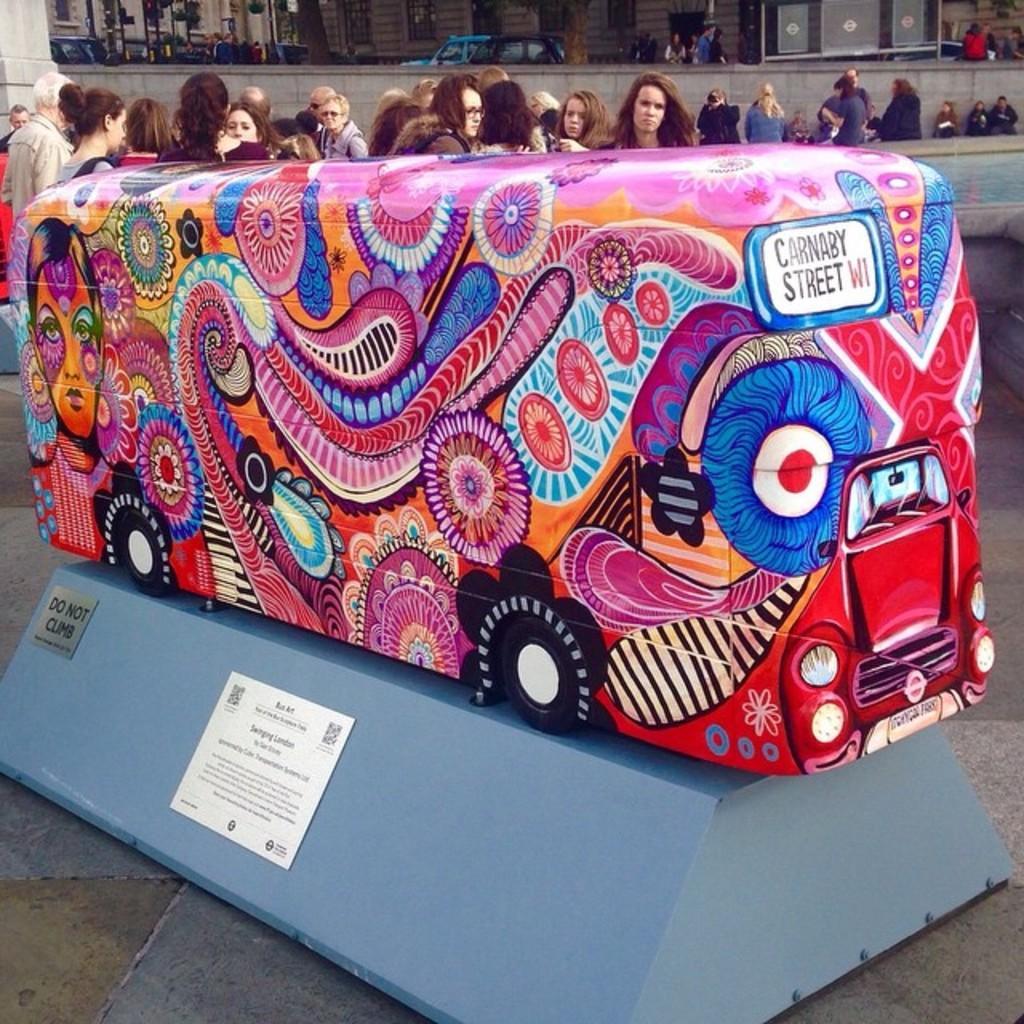How would you summarize this image in a sentence or two? In this image, I can see a colorful toy bus, which is placed on a ramp. These are the boards, which are attached to a ramp. I can see a group of people standing. At the top of the image, I think these are the vehicles and few people. This looks like a wall. 